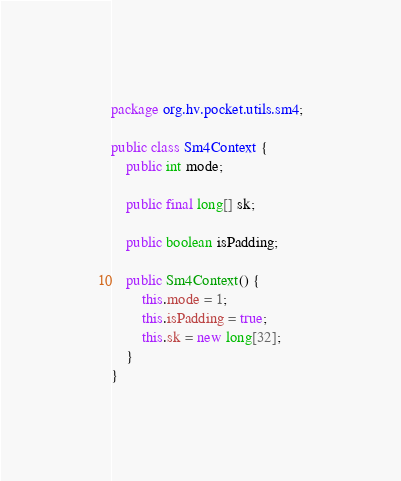Convert code to text. <code><loc_0><loc_0><loc_500><loc_500><_Java_>package org.hv.pocket.utils.sm4;

public class Sm4Context {
    public int mode;

    public final long[] sk;

    public boolean isPadding;

    public Sm4Context() {
        this.mode = 1;
        this.isPadding = true;
        this.sk = new long[32];
    }
}
</code> 